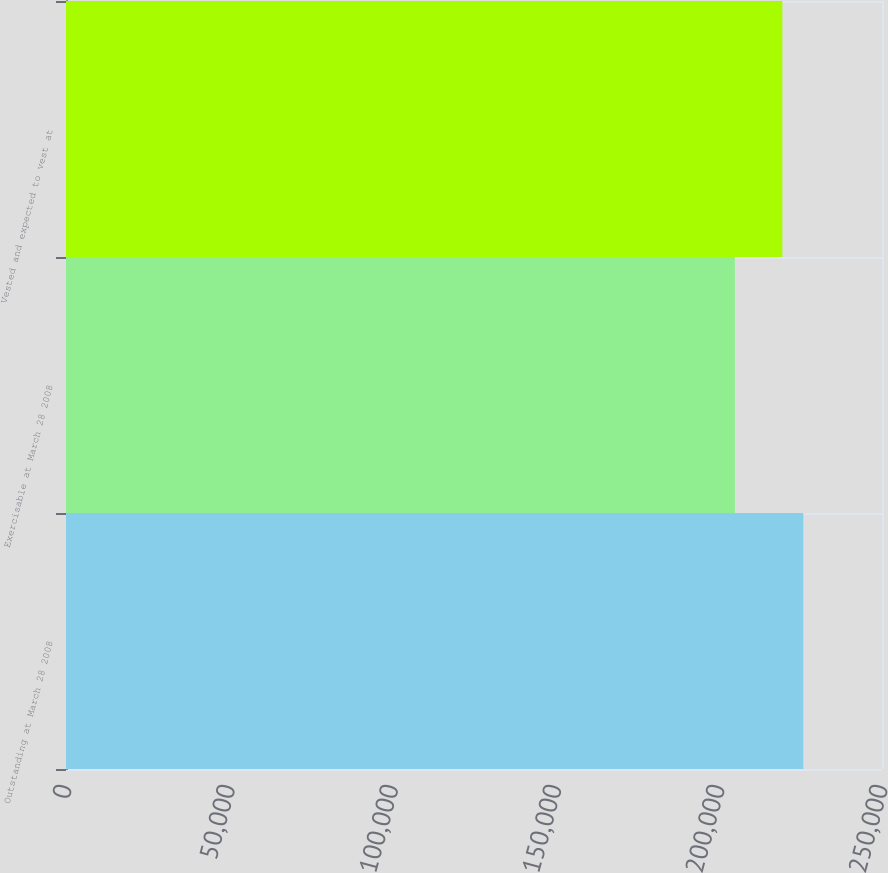<chart> <loc_0><loc_0><loc_500><loc_500><bar_chart><fcel>Outstanding at March 28 2008<fcel>Exercisable at March 28 2008<fcel>Vested and expected to vest at<nl><fcel>225899<fcel>204918<fcel>219469<nl></chart> 